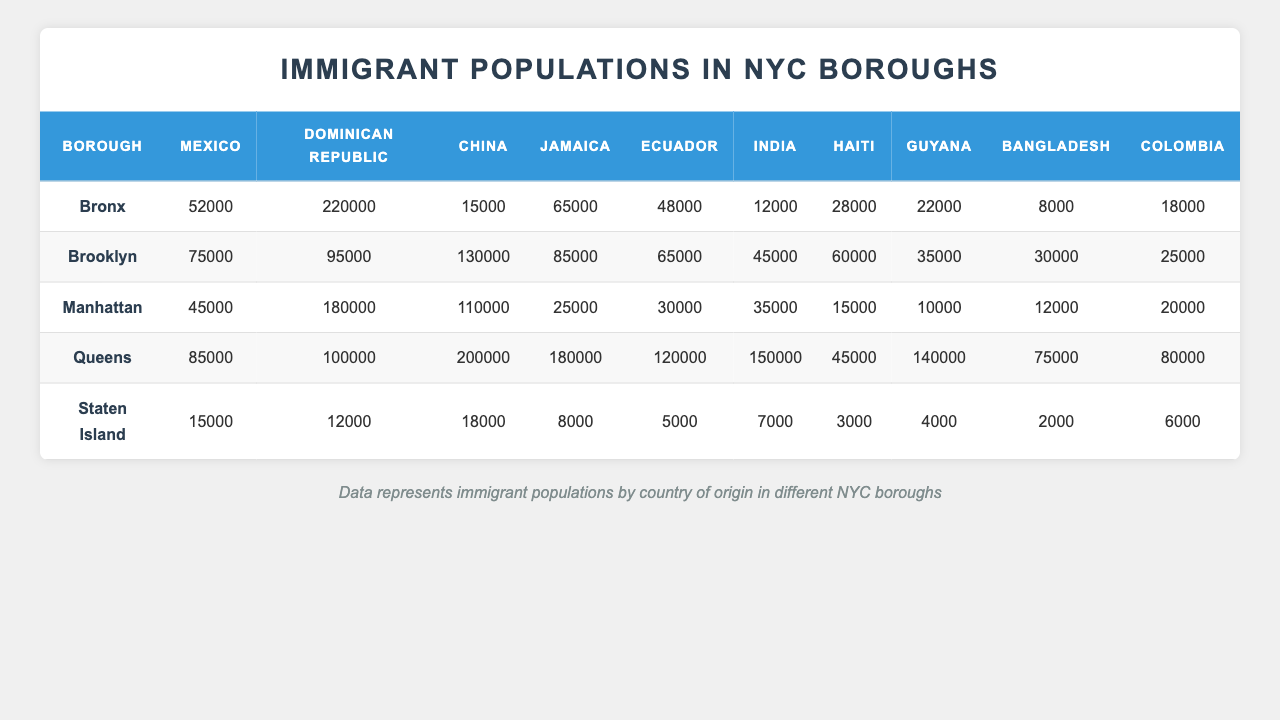What is the most significant immigrant group in the Bronx? In the Bronx, the Dominican Republic has the highest population among the immigrant groups listed, with 220,000 individuals.
Answer: Dominican Republic Which borough has the highest number of Chinese immigrants? Queens has the highest number of Chinese immigrants, with a reported population of 200,000.
Answer: Queens What is the total population of Jamaican immigrants in Brooklyn and Manhattan combined? For Brooklyn, the Jamaican population is 85,000, and for Manhattan, it is 25,000. The sum is 85,000 + 25,000 = 110,000.
Answer: 110,000 Is there more than 100,000 immigrants from Ecuador in Queens? In Queens, the Ecuadorian immigrant population is 120,000, which is indeed more than 100,000.
Answer: Yes How many more Mexican immigrants are in Brooklyn compared to Staten Island? Brooklyn has 75,000 Mexican immigrants and Staten Island has 15,000. The difference is 75,000 - 15,000 = 60,000.
Answer: 60,000 What is the average number of Haitian immigrants across all boroughs? To find the average, we first add the Haitian populations: Bronx (28,000) + Brooklyn (60,000) + Manhattan (15,000) + Queens (45,000) + Staten Island (3,000) = 151,000. Then, divide by the number of boroughs (5): 151,000 / 5 = 30,200.
Answer: 30,200 Which borough has the least number of immigrants from Colombia? Staten Island has the least number of Colombian immigrants, with a population of 6,000.
Answer: Staten Island What is the total number of Indian immigrants in all boroughs combined? The total for Indian immigrants is: Bronx (12,000) + Brooklyn (45,000) + Manhattan (35,000) + Queens (150,000) + Staten Island (7,000) = 249,000.
Answer: 249,000 Is the population of immigrants from Guyana greater in Queens than in the Bronx? The Guyanese immigrant population in Queens is 140,000 while in the Bronx it is 22,000, so yes, it is greater in Queens.
Answer: Yes If we consider the total population of immigrants from Mexico in all boroughs, what would that total be? The totals from each borough are: Bronx (52,000) + Brooklyn (75,000) + Manhattan (45,000) + Queens (85,000) + Staten Island (15,000). Adding them gives: 52,000 + 75,000 + 45,000 + 85,000 + 15,000 = 272,000.
Answer: 272,000 